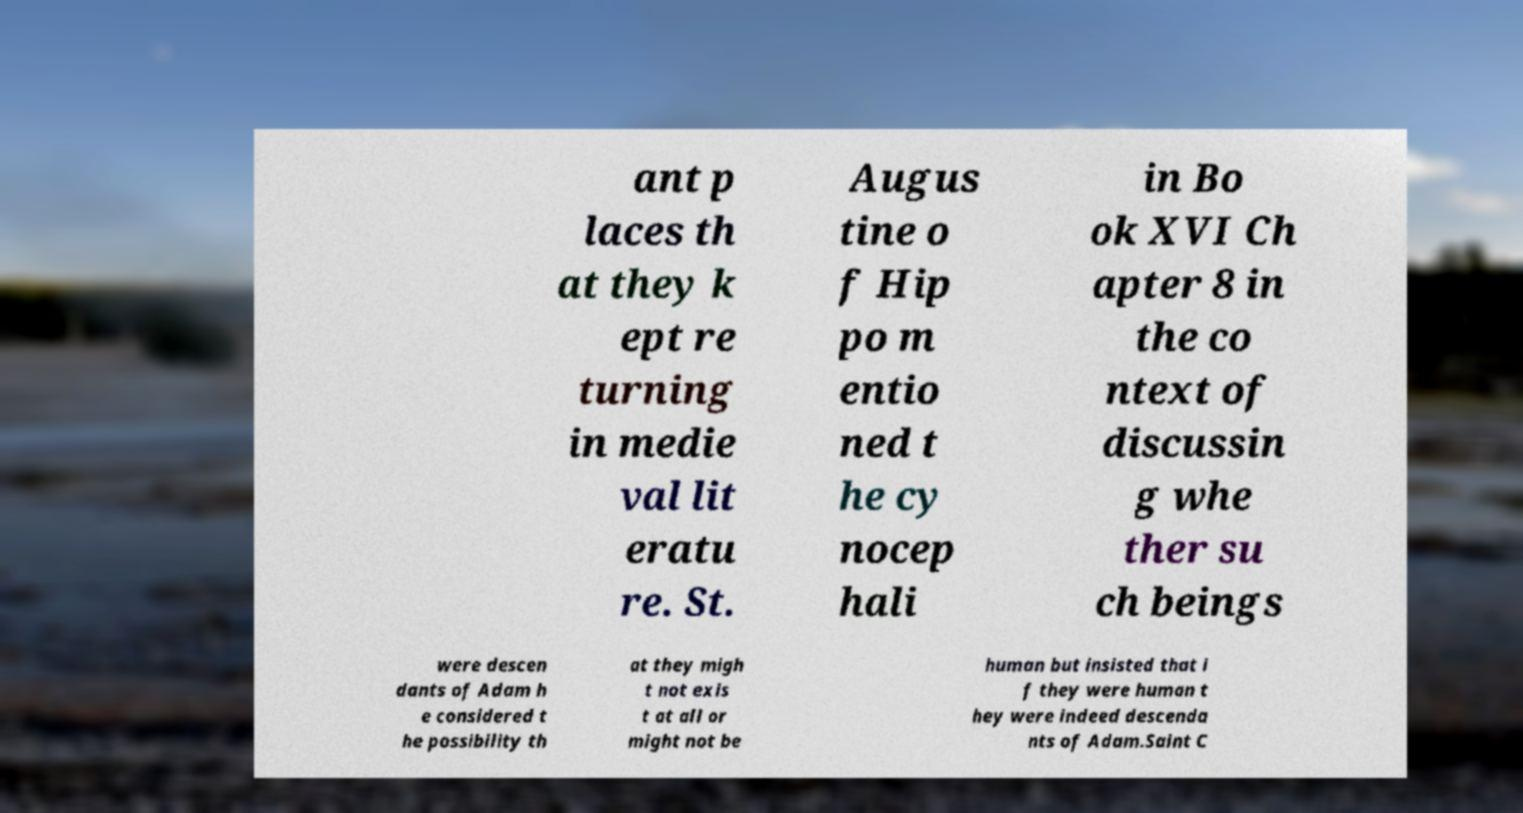Please identify and transcribe the text found in this image. ant p laces th at they k ept re turning in medie val lit eratu re. St. Augus tine o f Hip po m entio ned t he cy nocep hali in Bo ok XVI Ch apter 8 in the co ntext of discussin g whe ther su ch beings were descen dants of Adam h e considered t he possibility th at they migh t not exis t at all or might not be human but insisted that i f they were human t hey were indeed descenda nts of Adam.Saint C 